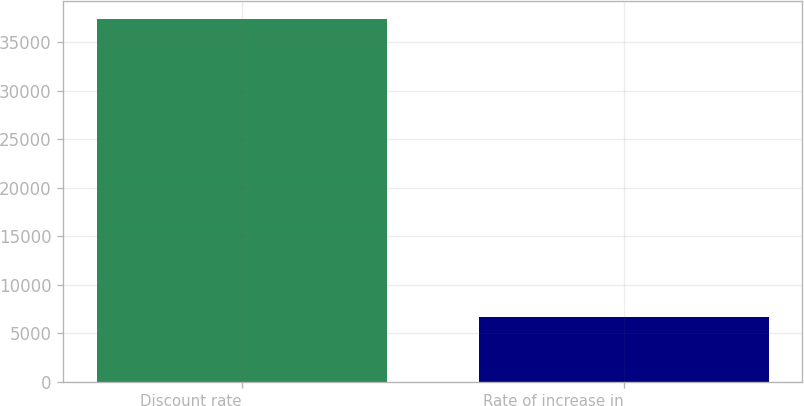Convert chart to OTSL. <chart><loc_0><loc_0><loc_500><loc_500><bar_chart><fcel>Discount rate<fcel>Rate of increase in<nl><fcel>37338<fcel>6706<nl></chart> 